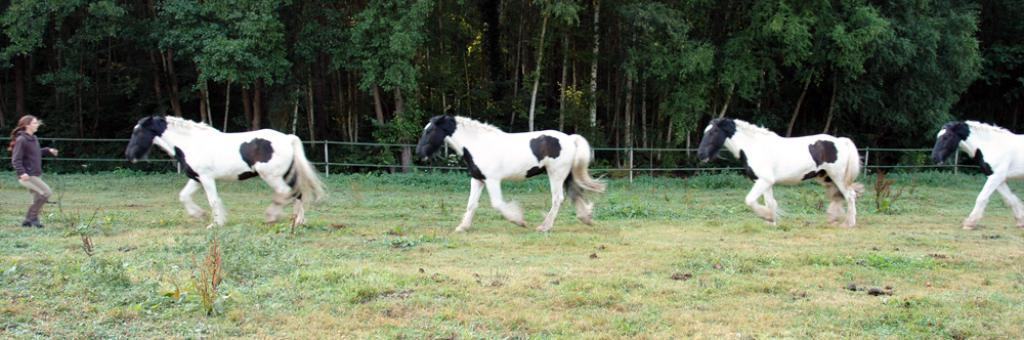Who is present in the image? There is a woman in the image. What animals can be seen on the ground in the image? There are horses on the ground in the image. What type of vegetation is present in the image? There are plants and grass in the image. What structure can be seen in the image? There is a fence in the image. What type of natural feature is visible in the image? There is a group of trees in the image. What type of account is being discussed in the image? There is no mention of an account in the image; it features a woman, horses, plants, grass, a fence, and a group of trees. Can you hear any bells ringing in the image? There is no sound present in the image, so it is not possible to determine if any bells are ringing. 